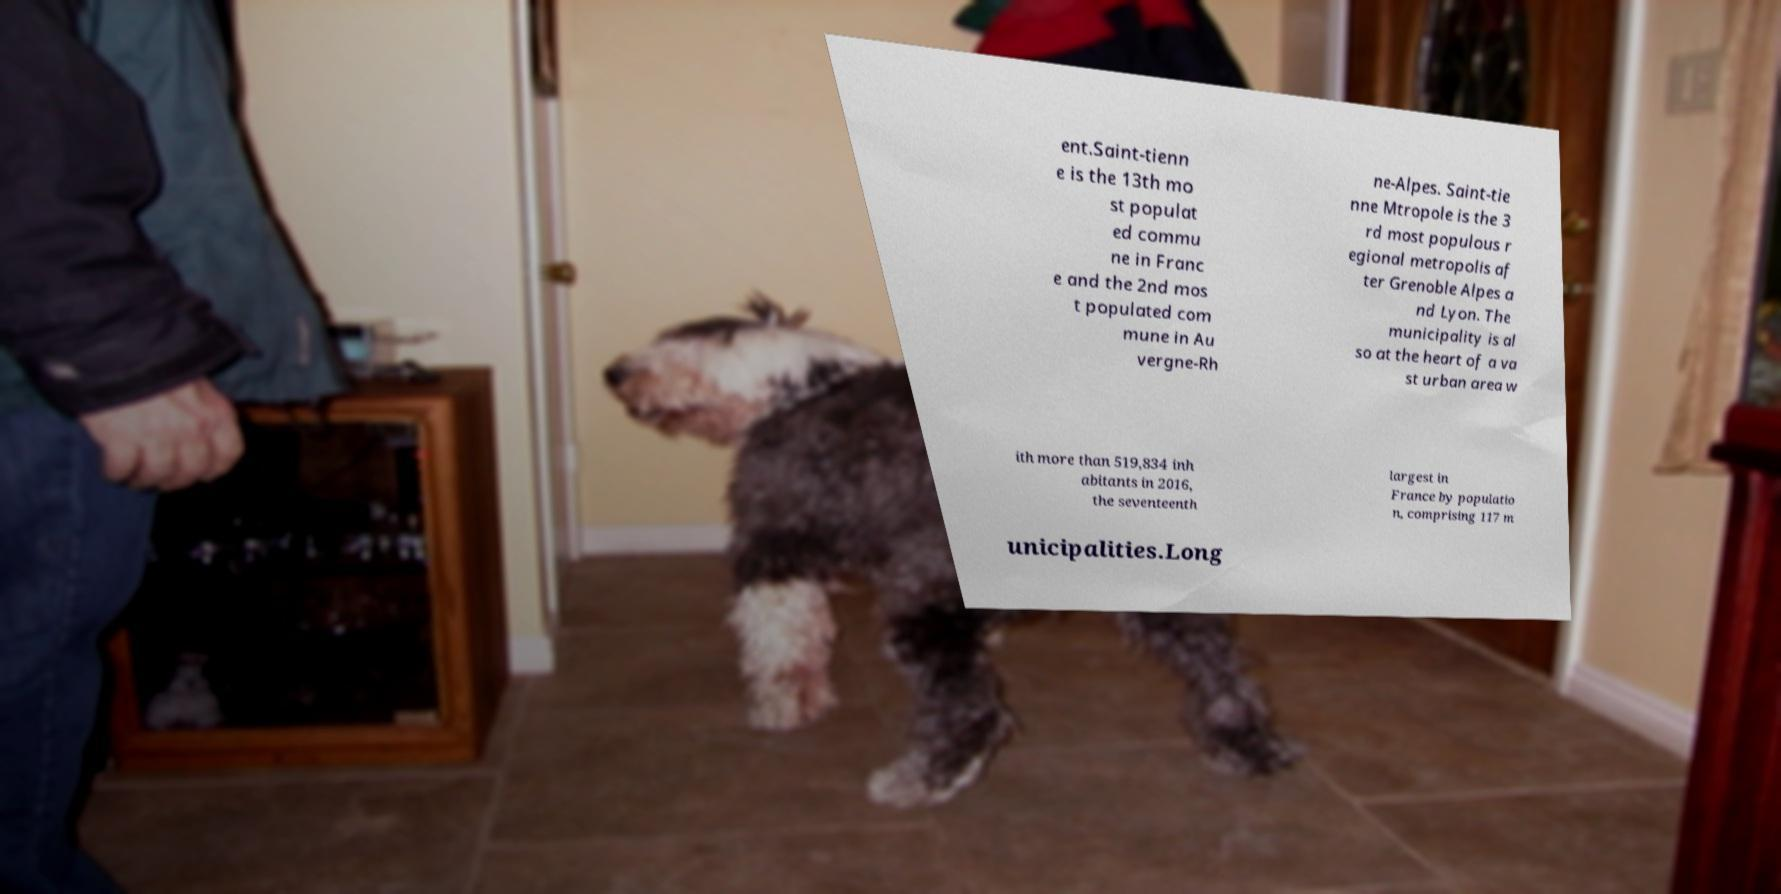I need the written content from this picture converted into text. Can you do that? ent.Saint-tienn e is the 13th mo st populat ed commu ne in Franc e and the 2nd mos t populated com mune in Au vergne-Rh ne-Alpes. Saint-tie nne Mtropole is the 3 rd most populous r egional metropolis af ter Grenoble Alpes a nd Lyon. The municipality is al so at the heart of a va st urban area w ith more than 519,834 inh abitants in 2016, the seventeenth largest in France by populatio n, comprising 117 m unicipalities.Long 